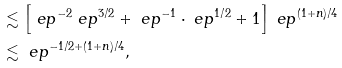Convert formula to latex. <formula><loc_0><loc_0><loc_500><loc_500>& \lesssim \left [ \ e p ^ { - 2 } \ e p ^ { 3 / 2 } + \ e p ^ { - 1 } \cdot \ e p ^ { 1 / 2 } + 1 \right ] \ e p ^ { ( 1 + n ) / 4 } \\ & \lesssim \ e p ^ { - 1 / 2 + ( 1 + n ) / 4 } ,</formula> 